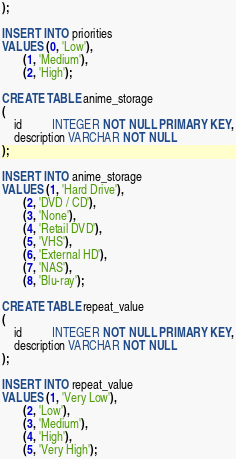<code> <loc_0><loc_0><loc_500><loc_500><_SQL_>);

INSERT INTO priorities
VALUES (0, 'Low'),
       (1, 'Medium'),
       (2, 'High');

CREATE TABLE anime_storage
(
    id          INTEGER NOT NULL PRIMARY KEY,
    description VARCHAR NOT NULL
);

INSERT INTO anime_storage
VALUES (1, 'Hard Drive'),
       (2, 'DVD / CD'),
       (3, 'None'),
       (4, 'Retail DVD'),
       (5, 'VHS'),
       (6, 'External HD'),
       (7, 'NAS'),
       (8, 'Blu-ray');

CREATE TABLE repeat_value
(
    id          INTEGER NOT NULL PRIMARY KEY,
    description VARCHAR NOT NULL
);

INSERT INTO repeat_value
VALUES (1, 'Very Low'),
       (2, 'Low'),
       (3, 'Medium'),
       (4, 'High'),
       (5, 'Very High');
</code> 